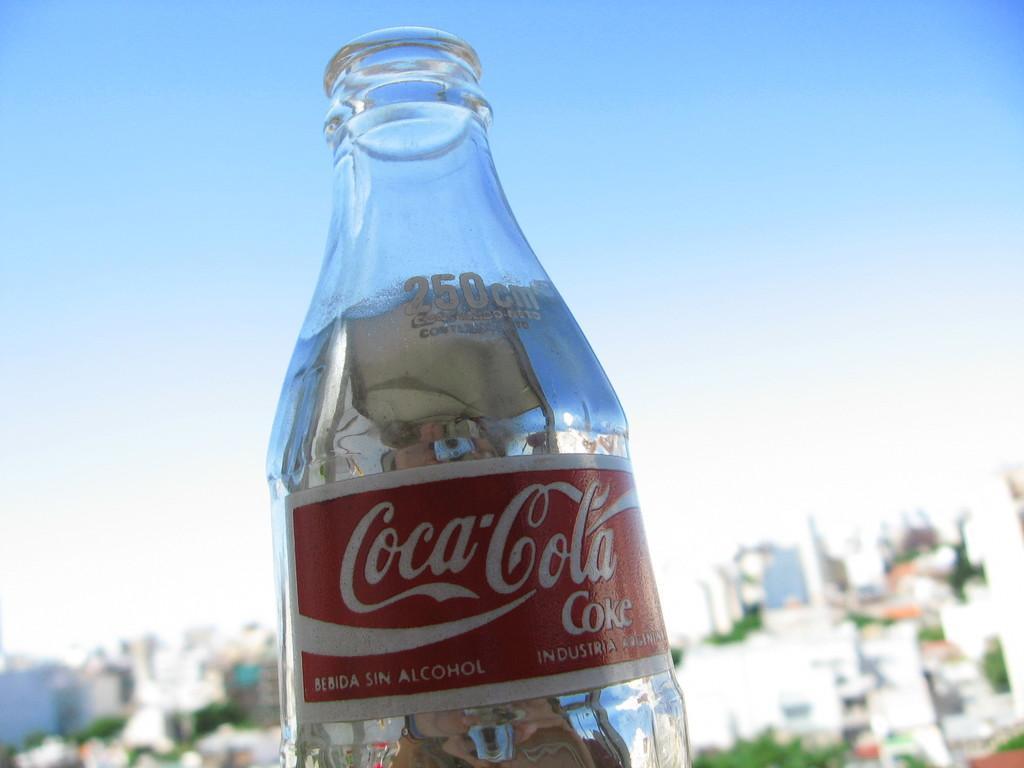Describe this image in one or two sentences. This is the picture of a Coca Cola bottle on which it is written with red and white color. 